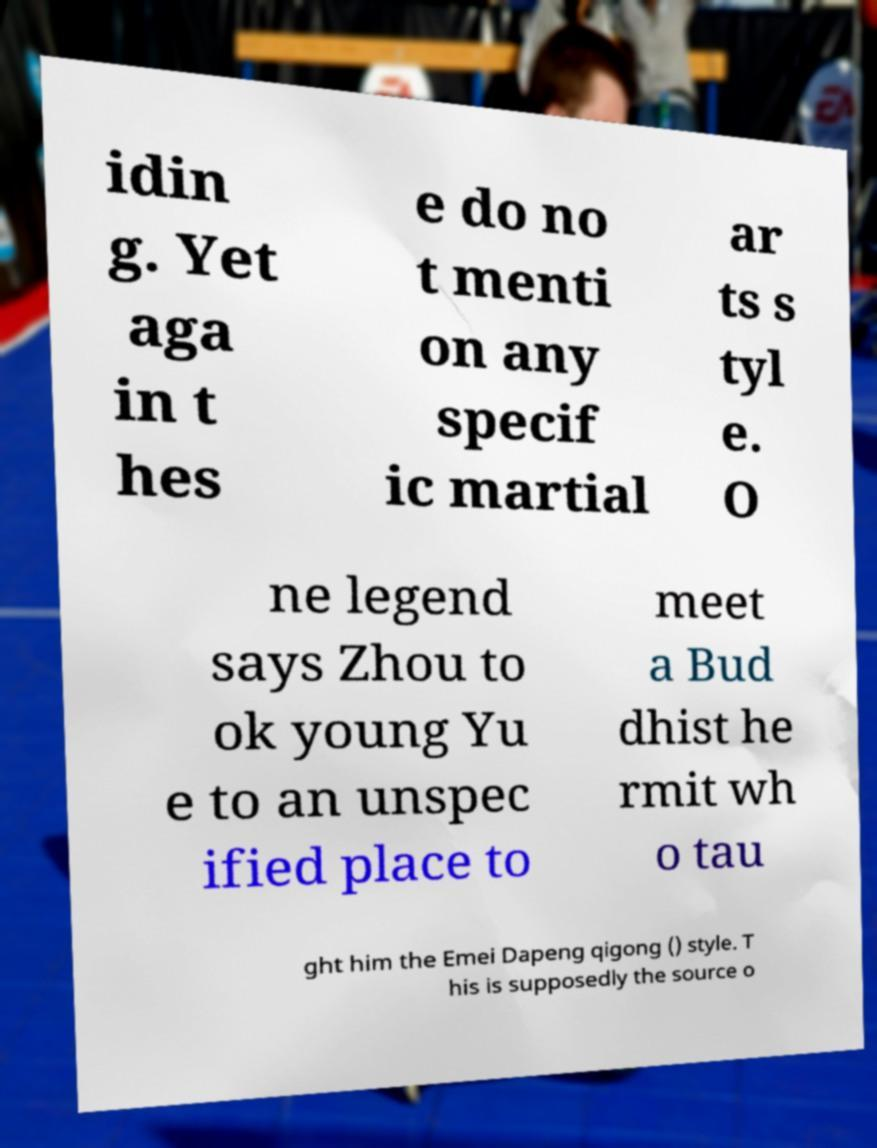I need the written content from this picture converted into text. Can you do that? idin g. Yet aga in t hes e do no t menti on any specif ic martial ar ts s tyl e. O ne legend says Zhou to ok young Yu e to an unspec ified place to meet a Bud dhist he rmit wh o tau ght him the Emei Dapeng qigong () style. T his is supposedly the source o 